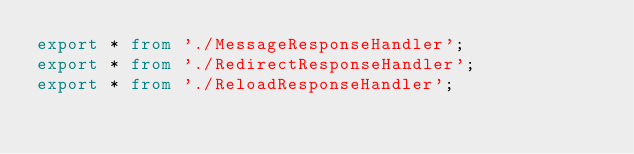<code> <loc_0><loc_0><loc_500><loc_500><_TypeScript_>export * from './MessageResponseHandler';
export * from './RedirectResponseHandler';
export * from './ReloadResponseHandler';</code> 